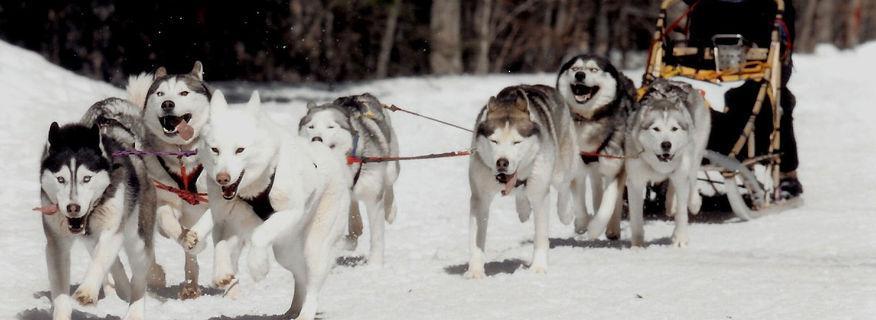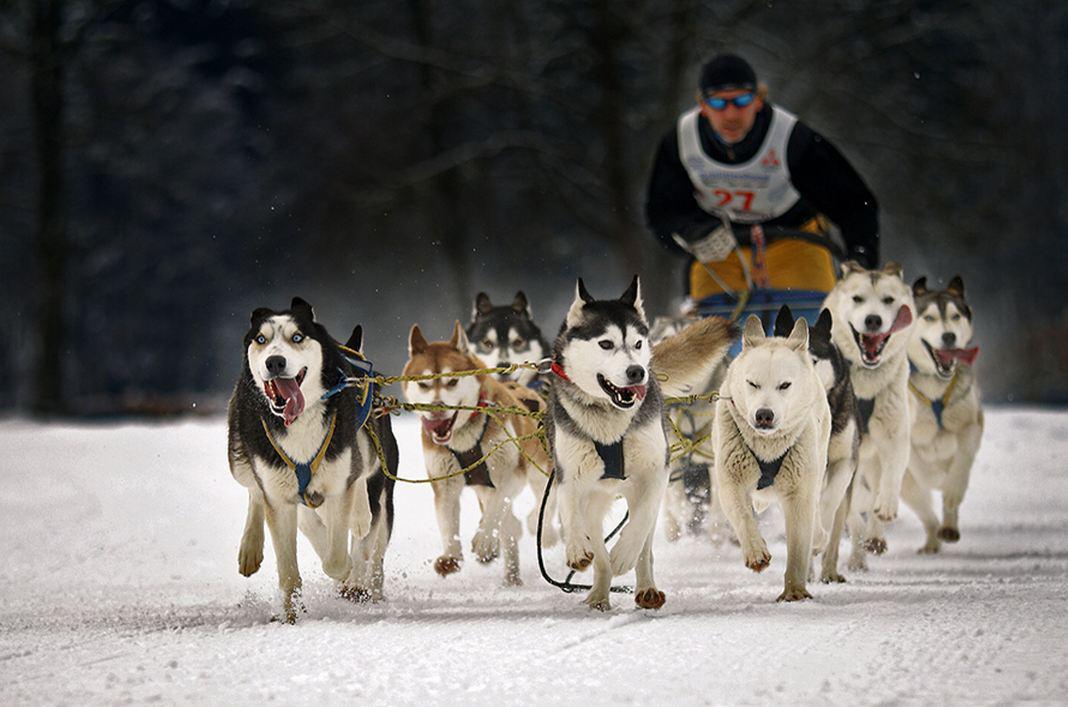The first image is the image on the left, the second image is the image on the right. Analyze the images presented: Is the assertion "The Huskies are running in both images." valid? Answer yes or no. Yes. 